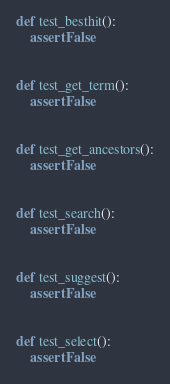Convert code to text. <code><loc_0><loc_0><loc_500><loc_500><_Python_>def test_besthit():
    assert False


def test_get_term():
    assert False


def test_get_ancestors():
    assert False


def test_search():
    assert False


def test_suggest():
    assert False


def test_select():
    assert False
</code> 